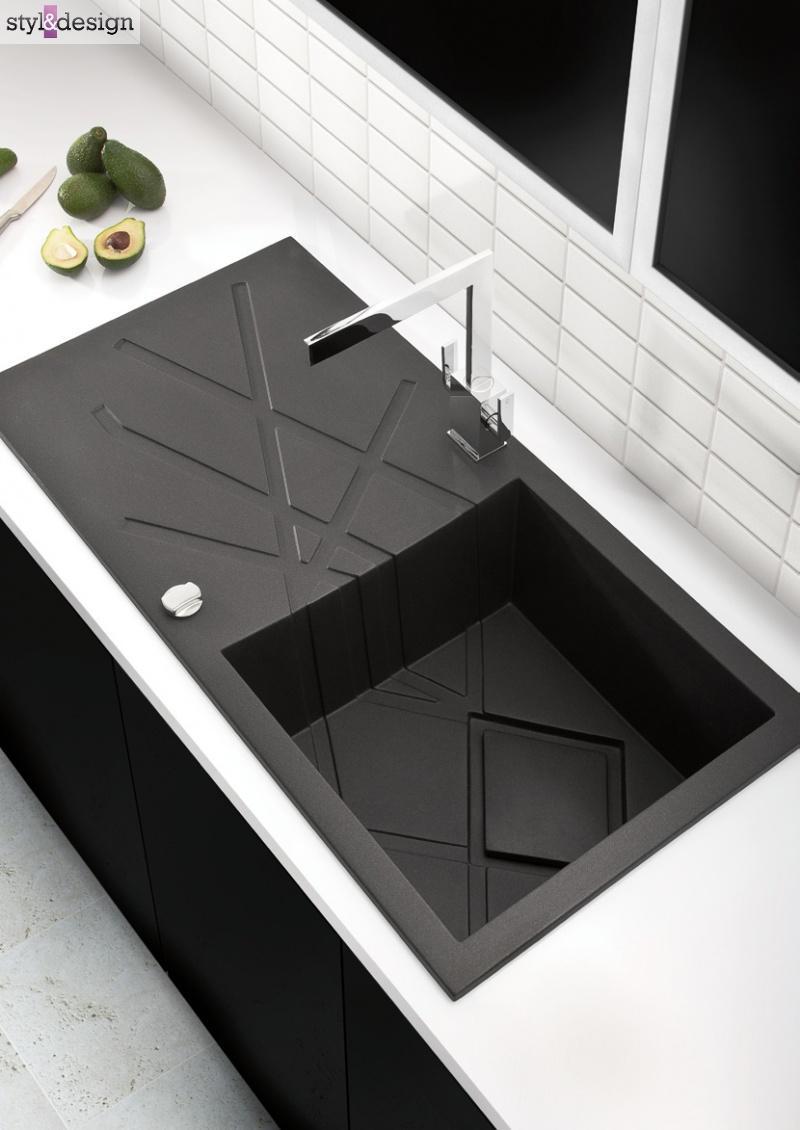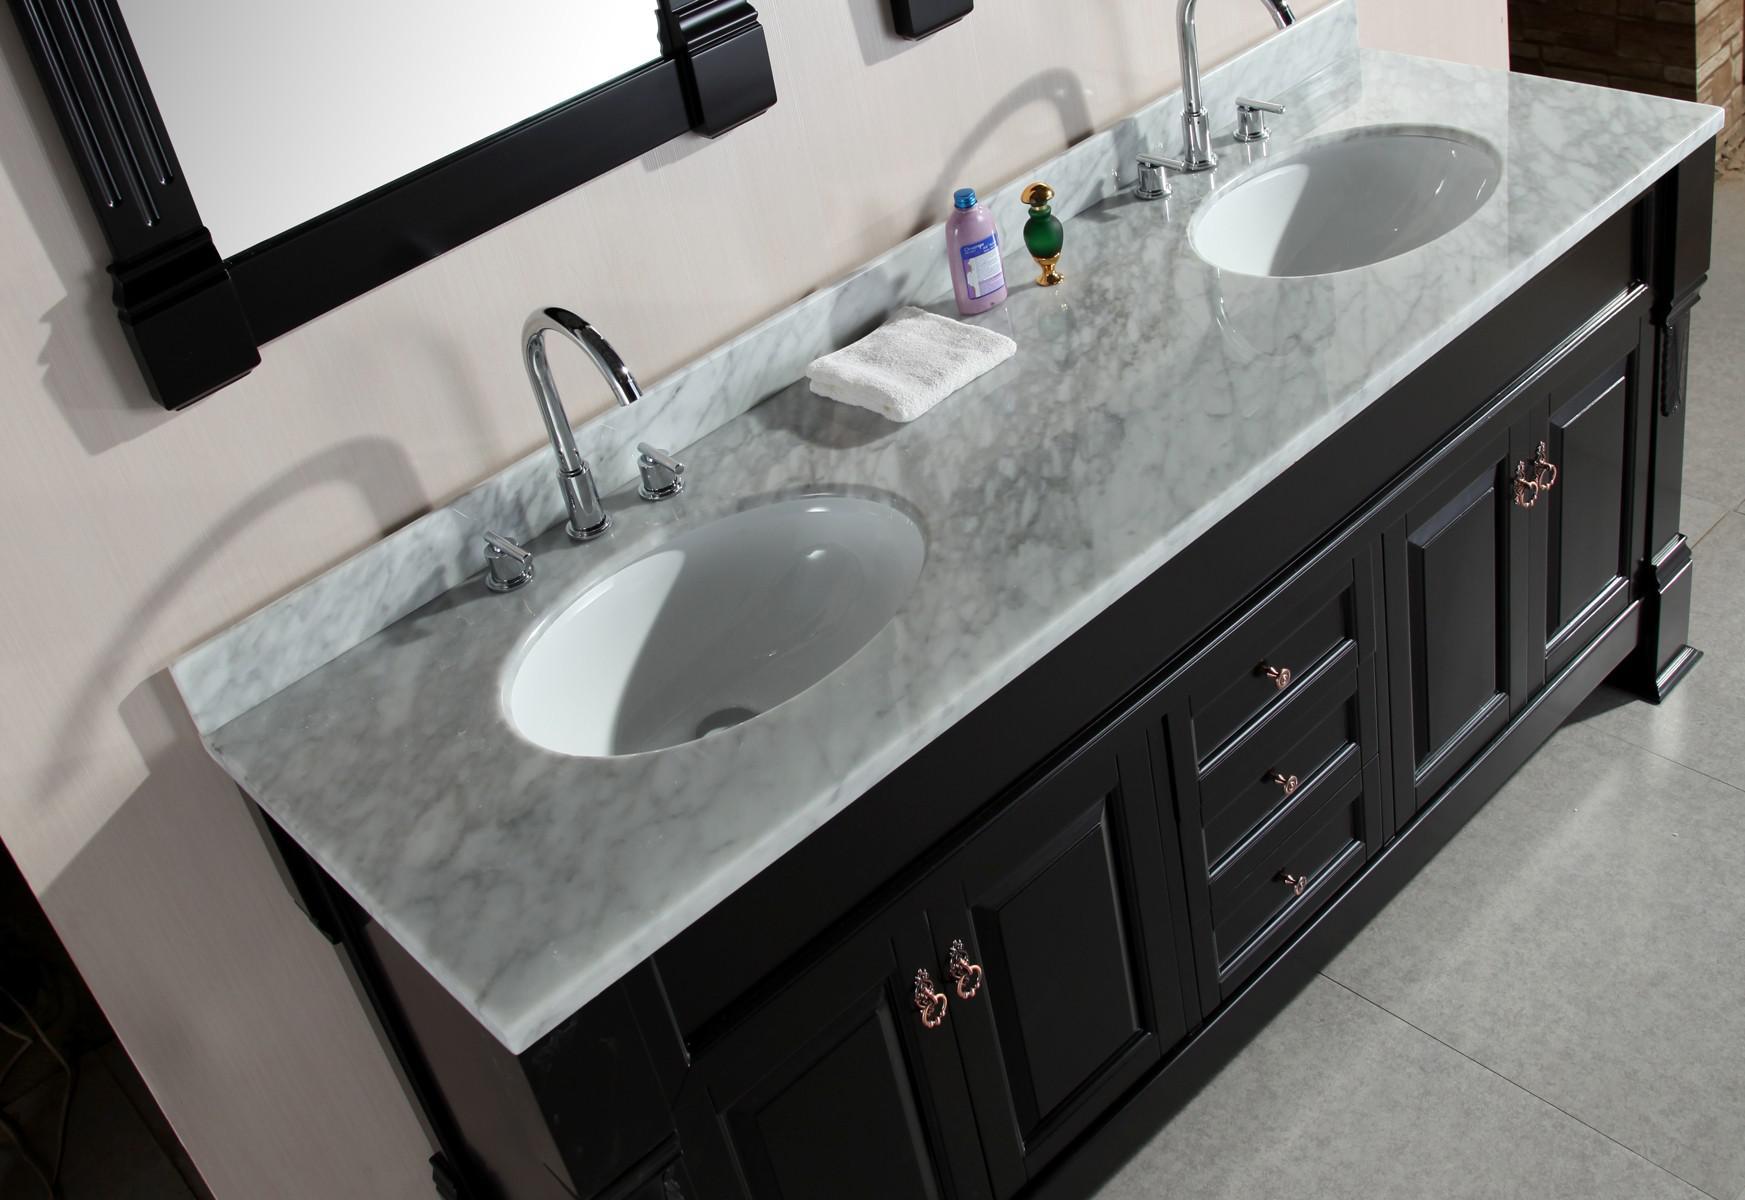The first image is the image on the left, the second image is the image on the right. Considering the images on both sides, is "An image shows a top-view of a black-and-white sink and vanity combination, with two rectangular sinks inset in the counter, and a mirror above each sink." valid? Answer yes or no. No. The first image is the image on the left, the second image is the image on the right. Given the left and right images, does the statement "The counter in the image on the left is black and has two white sinks." hold true? Answer yes or no. No. 